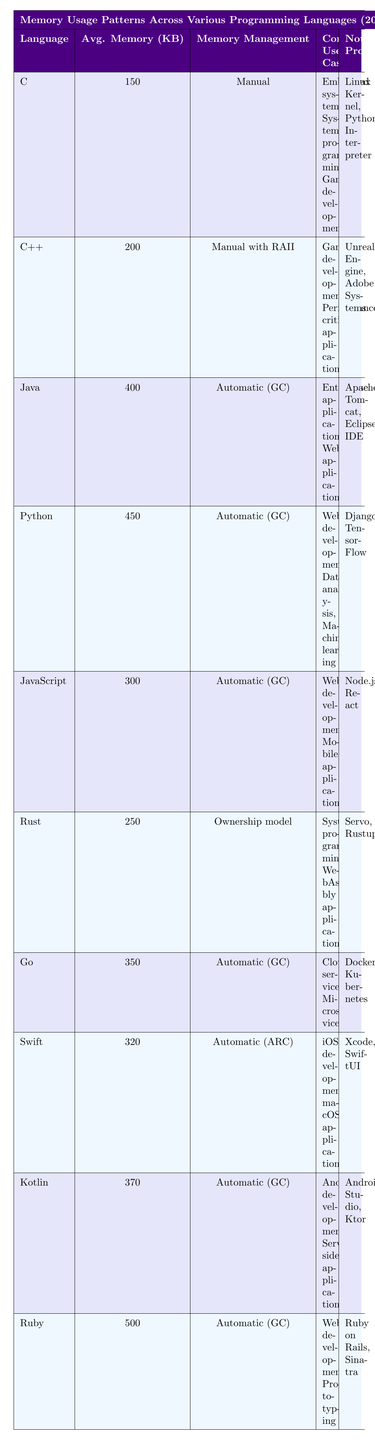What is the average memory usage for the Python programming language? From the table, the average memory usage for Python is directly stated as 450 KB.
Answer: 450 KB Which programming language has the lowest average memory usage? The table shows that C has the lowest average memory usage at 150 KB.
Answer: C Is memory management in Java automatic? The data indicates that Java uses automatic memory management through Garbage Collection, so the answer is yes.
Answer: Yes How does the average memory usage of C++ compare to that of Rust? C++ has an average memory usage of 200 KB and Rust has 250 KB. Since 200 is less than 250, C++ uses less memory than Rust.
Answer: C++ uses less memory than Rust What is the total average memory usage of Java and Kotlin combined? The average memory usage of Java is 400 KB and for Kotlin, it is 370 KB. Adding them together gives 400 + 370 = 770 KB.
Answer: 770 KB What programming languages use automatic garbage collection for memory management? The table lists Java, Python, JavaScript, Go, Kotlin, and Ruby as using automatic garbage collection.
Answer: Java, Python, JavaScript, Go, Kotlin, Ruby Which language has a higher average memory usage, Go or Swift? Go has an average memory usage of 350 KB while Swift has 320 KB. Since 350 is greater than 320, Go uses more memory than Swift.
Answer: Go uses more memory than Swift What can you infer about the memory management style of Ruby? The data specifies that Ruby employs automatic garbage collection for memory management, indicating that the programmer does not manually manage memory.
Answer: Automatic garbage collection Among the languages listed, which is most suited for embedded systems based on memory usage patterns? C is marked as having the lowest average memory usage (150 KB) and is also cited for use in embedded systems, making it the most suitable.
Answer: C Which two programming languages have similar average memory usage, and what is that usage? C++ has an average usage of 200 KB, and Rust has 250 KB, but neither are similar. However, Java with 400 KB is often regarded for applications like JavaScript at 300 KB.
Answer: None, they differ significantly If a developer is focused on web development and wants to minimize memory usage, which language should they consider? The languages listed for web development are JavaScript (300 KB) and Python (450 KB), making JavaScript the better choice for memory minimization based on its lower average usage.
Answer: JavaScript 